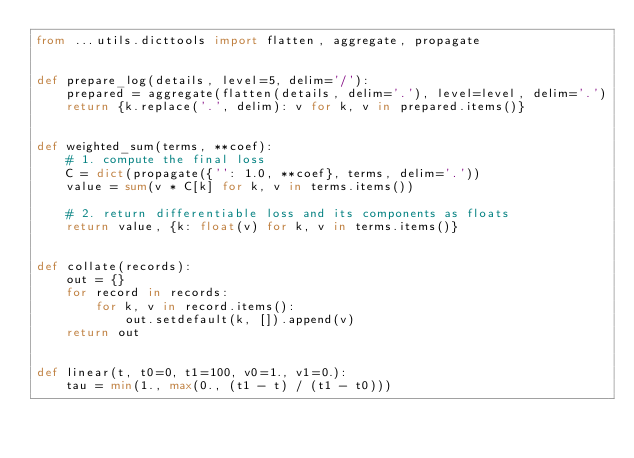Convert code to text. <code><loc_0><loc_0><loc_500><loc_500><_Python_>from ...utils.dicttools import flatten, aggregate, propagate


def prepare_log(details, level=5, delim='/'):
    prepared = aggregate(flatten(details, delim='.'), level=level, delim='.')
    return {k.replace('.', delim): v for k, v in prepared.items()}


def weighted_sum(terms, **coef):
    # 1. compute the final loss
    C = dict(propagate({'': 1.0, **coef}, terms, delim='.'))
    value = sum(v * C[k] for k, v in terms.items())

    # 2. return differentiable loss and its components as floats
    return value, {k: float(v) for k, v in terms.items()}


def collate(records):
    out = {}
    for record in records:
        for k, v in record.items():
            out.setdefault(k, []).append(v)
    return out


def linear(t, t0=0, t1=100, v0=1., v1=0.):
    tau = min(1., max(0., (t1 - t) / (t1 - t0)))</code> 